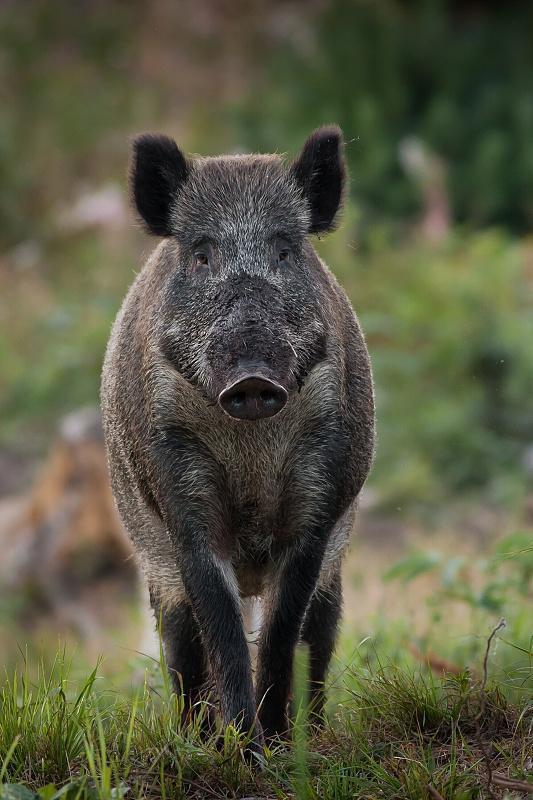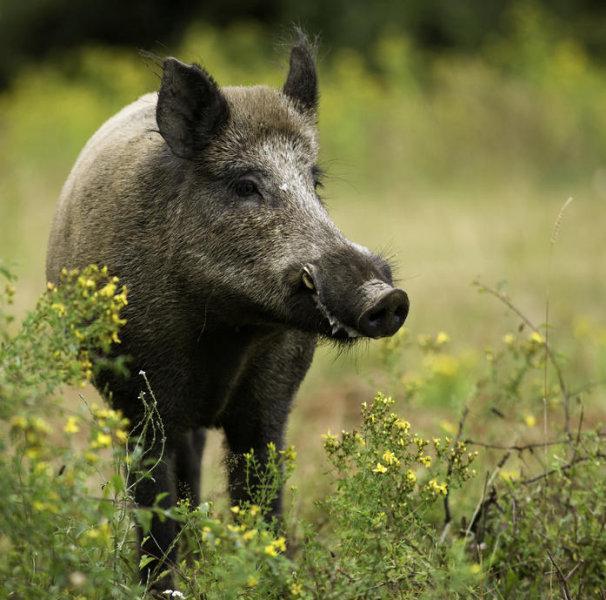The first image is the image on the left, the second image is the image on the right. Assess this claim about the two images: "One image shows a single wild pig with its head and body facing forward, and the other image shows a single standing wild pig with its head and body in profile.". Correct or not? Answer yes or no. No. The first image is the image on the left, the second image is the image on the right. For the images shown, is this caption "The pig in the image on the left is facing the camera." true? Answer yes or no. Yes. 